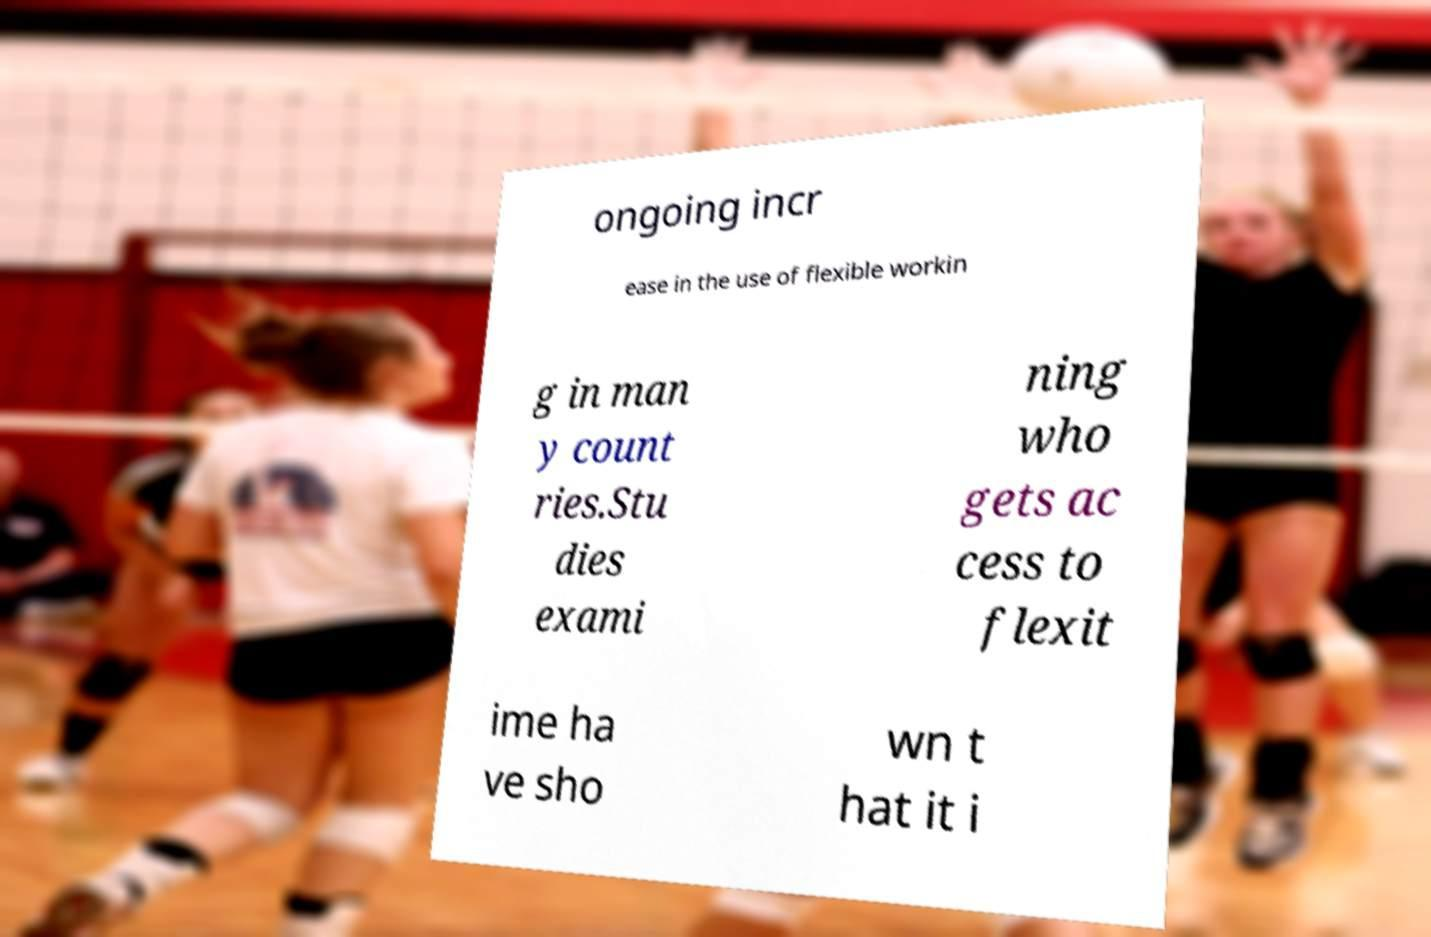Could you extract and type out the text from this image? ongoing incr ease in the use of flexible workin g in man y count ries.Stu dies exami ning who gets ac cess to flexit ime ha ve sho wn t hat it i 